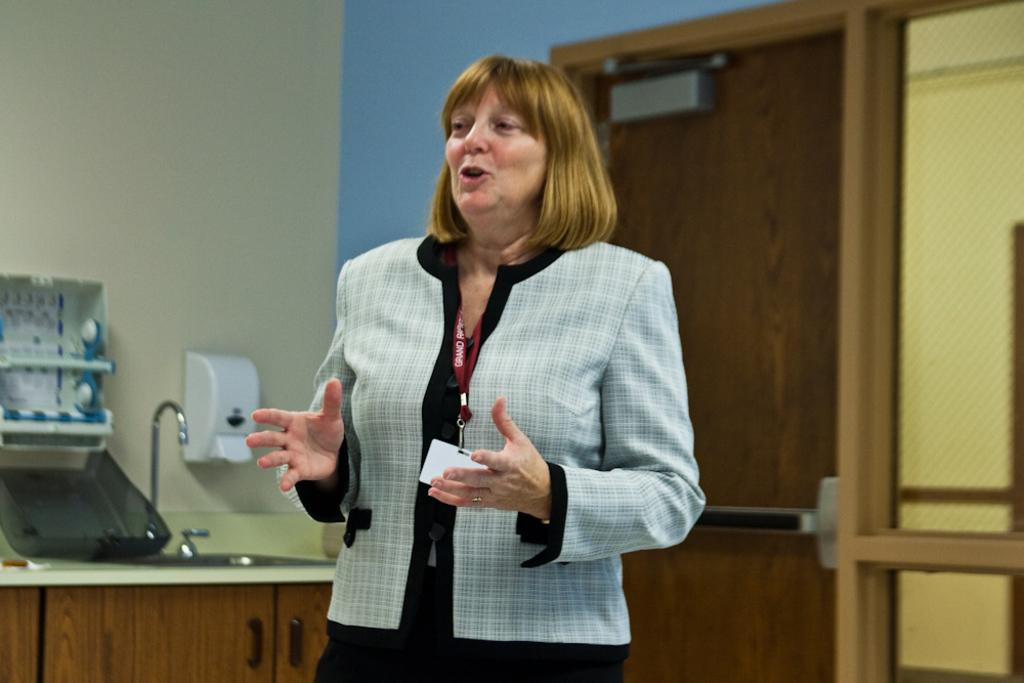What is the main subject in the image? There is a woman standing in the image. What can be seen near the woman? There is a sink with a tap in the image. Are there any storage units visible in the image? Yes, there is a cupboard in the image. What is attached to the wall in the image? There is a tissue paper holder on a wall in the image. Is there a way to enter or exit the room in the image? Yes, there is a door in the image. How many zephyrs are visible in the image? There are no zephyrs present in the image. What type of apples are being used as decoration in the image? There are no apples present in the image. 